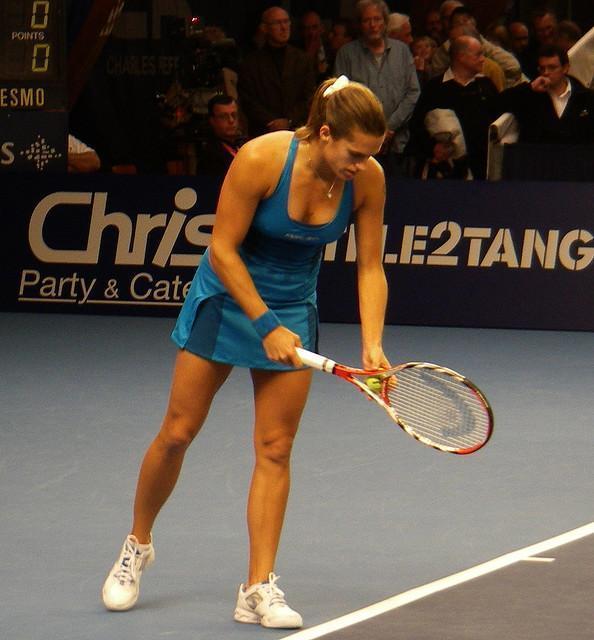How many people are in the photo?
Give a very brief answer. 7. 